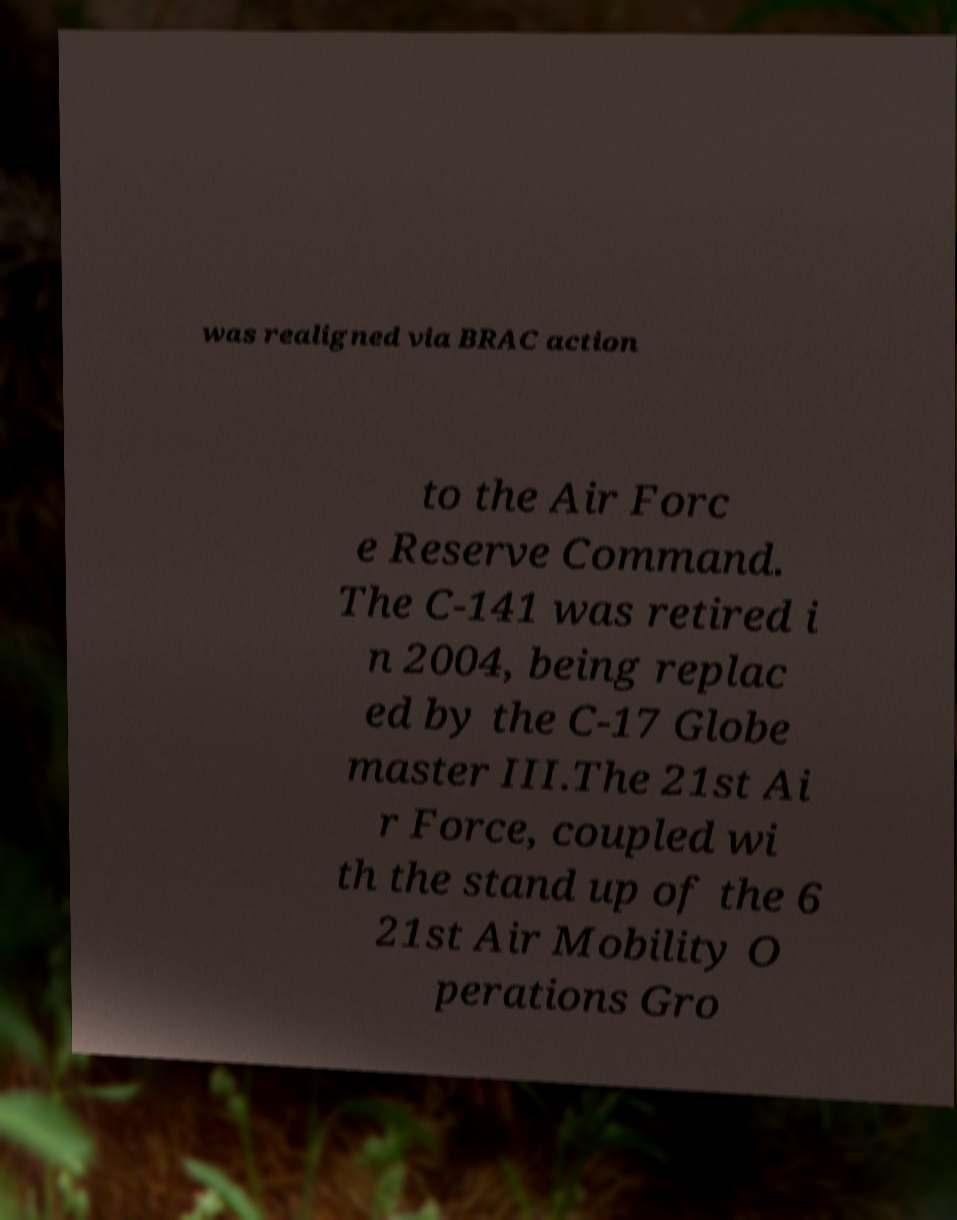Please read and relay the text visible in this image. What does it say? was realigned via BRAC action to the Air Forc e Reserve Command. The C-141 was retired i n 2004, being replac ed by the C-17 Globe master III.The 21st Ai r Force, coupled wi th the stand up of the 6 21st Air Mobility O perations Gro 